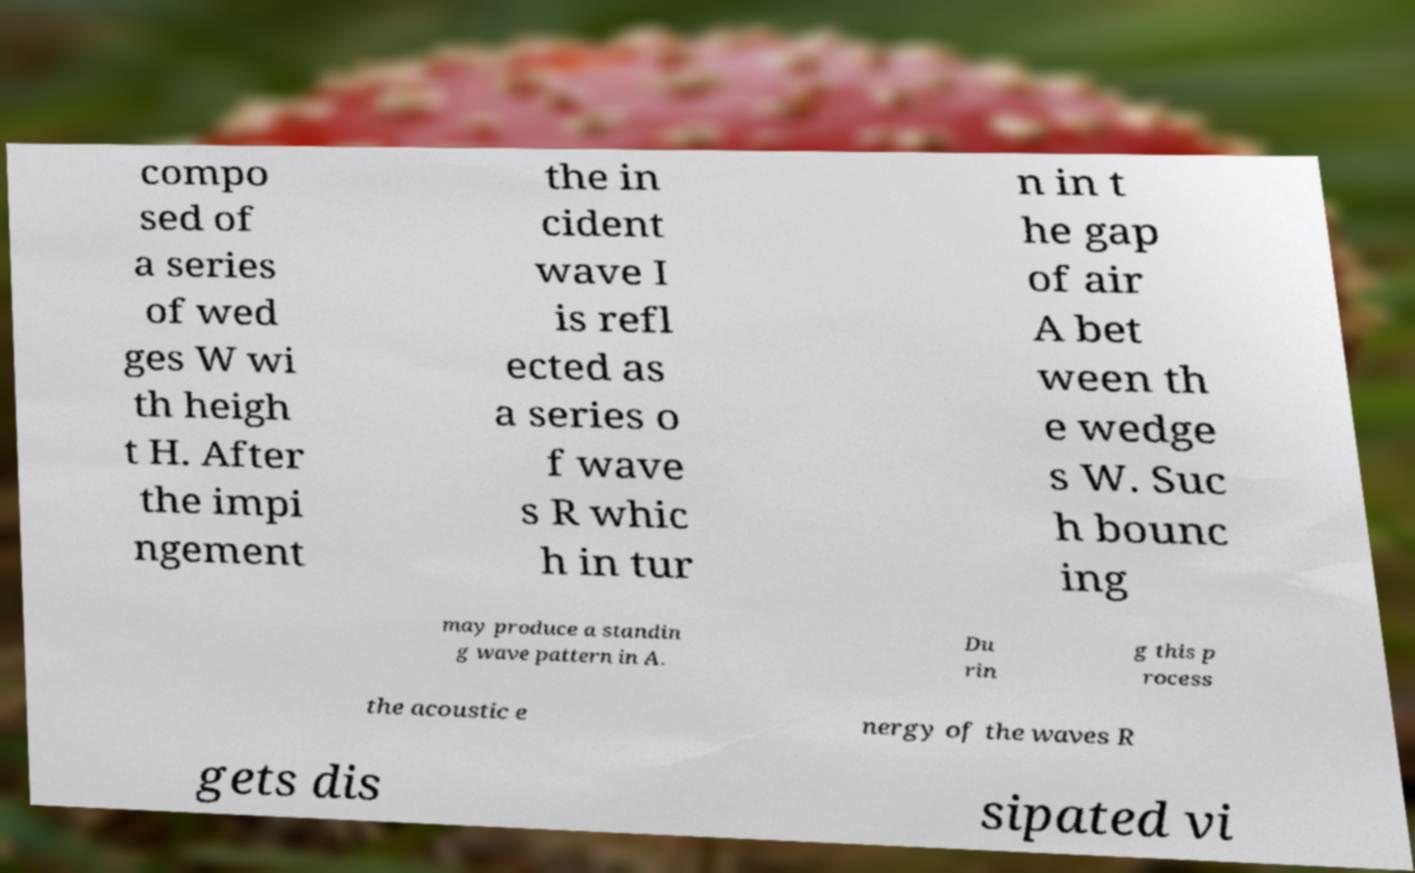I need the written content from this picture converted into text. Can you do that? compo sed of a series of wed ges W wi th heigh t H. After the impi ngement the in cident wave I is refl ected as a series o f wave s R whic h in tur n in t he gap of air A bet ween th e wedge s W. Suc h bounc ing may produce a standin g wave pattern in A. Du rin g this p rocess the acoustic e nergy of the waves R gets dis sipated vi 